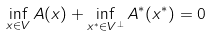<formula> <loc_0><loc_0><loc_500><loc_500>\inf _ { x \in V } A ( x ) + \inf _ { x ^ { * } \in V ^ { \bot } } A ^ { * } ( x ^ { * } ) = 0</formula> 